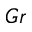Convert formula to latex. <formula><loc_0><loc_0><loc_500><loc_500>G r</formula> 